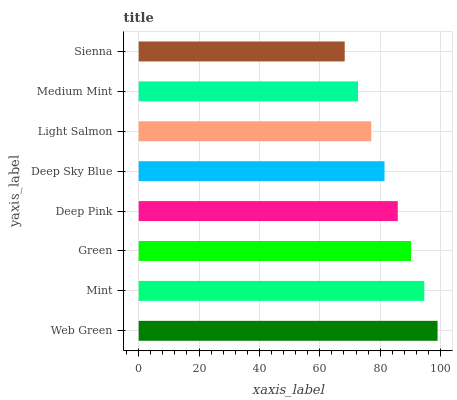Is Sienna the minimum?
Answer yes or no. Yes. Is Web Green the maximum?
Answer yes or no. Yes. Is Mint the minimum?
Answer yes or no. No. Is Mint the maximum?
Answer yes or no. No. Is Web Green greater than Mint?
Answer yes or no. Yes. Is Mint less than Web Green?
Answer yes or no. Yes. Is Mint greater than Web Green?
Answer yes or no. No. Is Web Green less than Mint?
Answer yes or no. No. Is Deep Pink the high median?
Answer yes or no. Yes. Is Deep Sky Blue the low median?
Answer yes or no. Yes. Is Light Salmon the high median?
Answer yes or no. No. Is Light Salmon the low median?
Answer yes or no. No. 